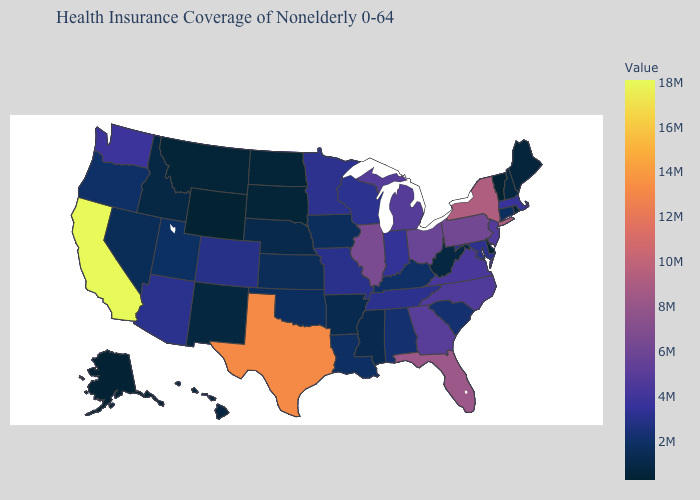Among the states that border Virginia , which have the lowest value?
Short answer required. West Virginia. Does Vermont have the lowest value in the USA?
Concise answer only. Yes. Does South Carolina have the highest value in the South?
Be succinct. No. Does Colorado have the highest value in the West?
Be succinct. No. Does Montana have the highest value in the USA?
Give a very brief answer. No. Does the map have missing data?
Concise answer only. No. Among the states that border Kentucky , which have the highest value?
Give a very brief answer. Illinois. 